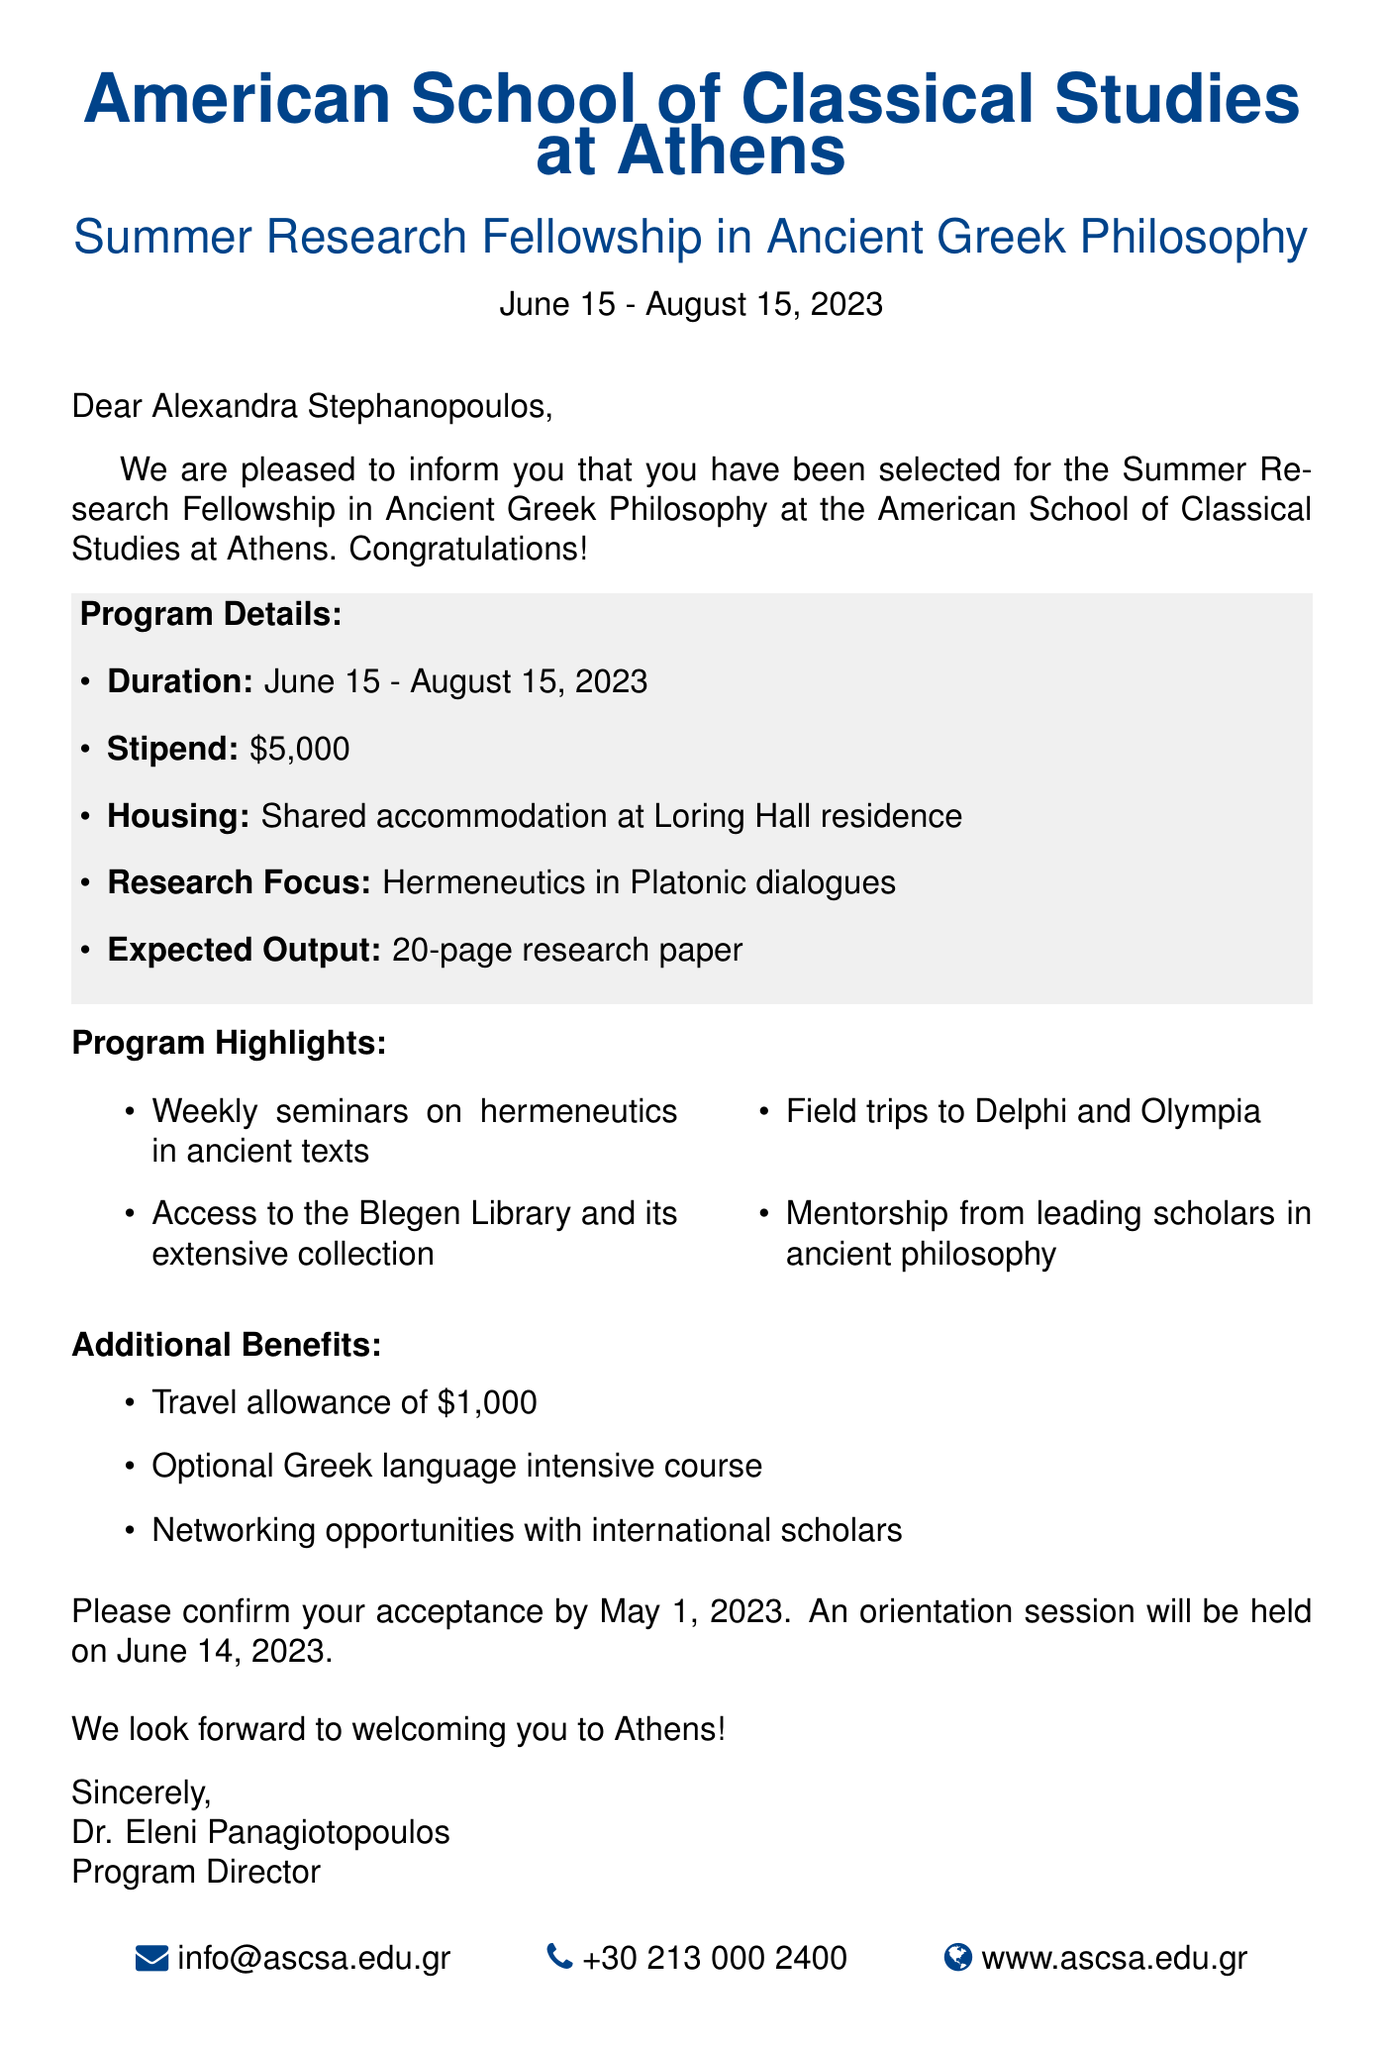What is the name of the recipient? The recipient's name is stated at the beginning of the document.
Answer: Alexandra Stephanopoulos What is the duration of the program? The specific dates for the program duration are mentioned in the document.
Answer: June 15 - August 15, 2023 What is the stipend amount for the fellowship? The stipend amount is explicitly stated in the program details.
Answer: $5,000 Who is the program director? The name of the program director is listed at the end of the document.
Answer: Dr. Eleni Panagiotopoulos What are the field trip locations mentioned? The document lists field trip sites as part of the program highlights.
Answer: Delphi and Olympia What is the expected output of the research? The document specifies the expected output in the context of the research project.
Answer: 20-page research paper What is included in the additional benefits? The document outlines the additional benefits provided to the fellows.
Answer: Travel allowance of $1,000 What is the orientation date? The orientation date is mentioned towards the end of the document.
Answer: June 14, 2023 What is the focus of the research? The specific focus of the research is explicitly mentioned in the program details.
Answer: Hermeneutics in Platonic dialogues 